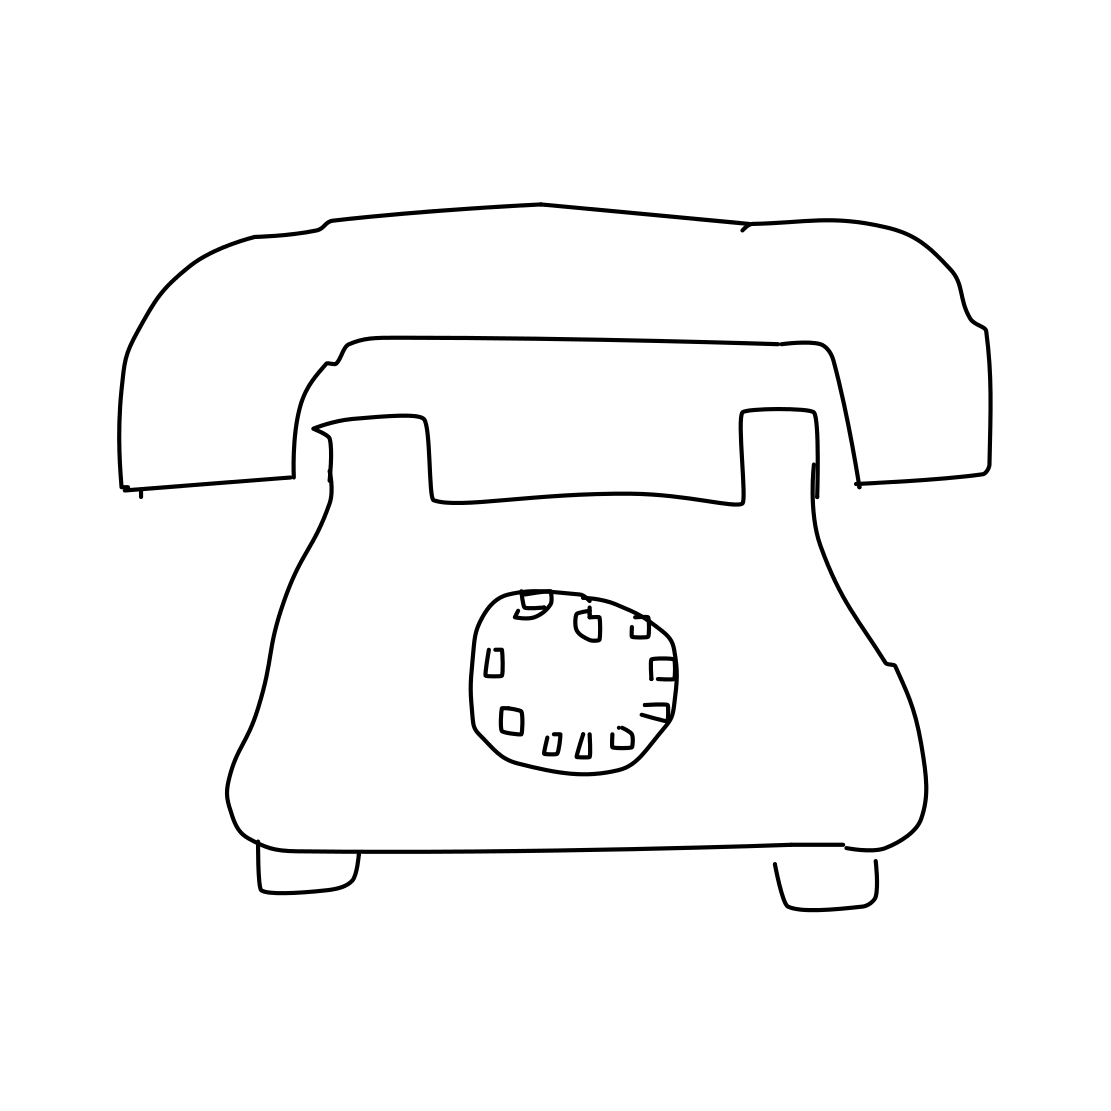What era is the telephone in the image from? The telephone in the image is styled like models that were common in the mid-20th century, particularly reminiscent of designs from the 1940s to the 1970s. 